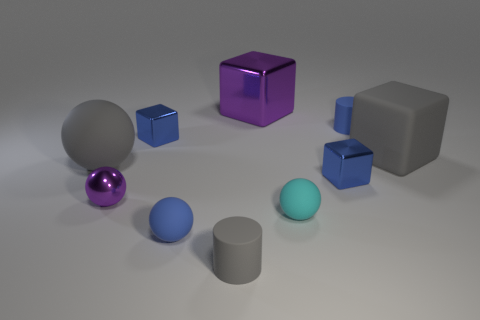Are there any patterns or consistencies in the arrangement of shapes? While there's no rigid pattern, the objects are arranged roughly by size with the smaller objects to the left and larger to the right, suggesting a positional consistency based on size. 